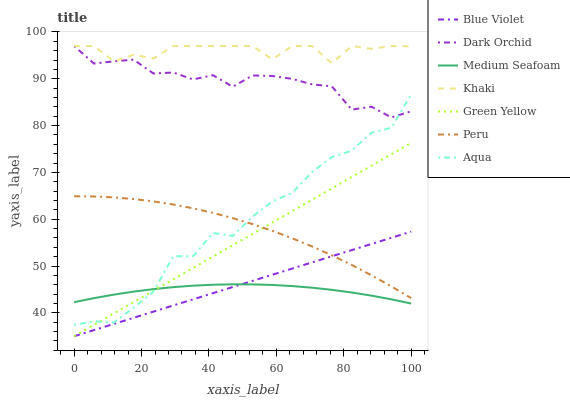Does Medium Seafoam have the minimum area under the curve?
Answer yes or no. Yes. Does Khaki have the maximum area under the curve?
Answer yes or no. Yes. Does Aqua have the minimum area under the curve?
Answer yes or no. No. Does Aqua have the maximum area under the curve?
Answer yes or no. No. Is Green Yellow the smoothest?
Answer yes or no. Yes. Is Aqua the roughest?
Answer yes or no. Yes. Is Dark Orchid the smoothest?
Answer yes or no. No. Is Dark Orchid the roughest?
Answer yes or no. No. Does Aqua have the lowest value?
Answer yes or no. No. Does Aqua have the highest value?
Answer yes or no. No. Is Peru less than Khaki?
Answer yes or no. Yes. Is Khaki greater than Green Yellow?
Answer yes or no. Yes. Does Peru intersect Khaki?
Answer yes or no. No. 